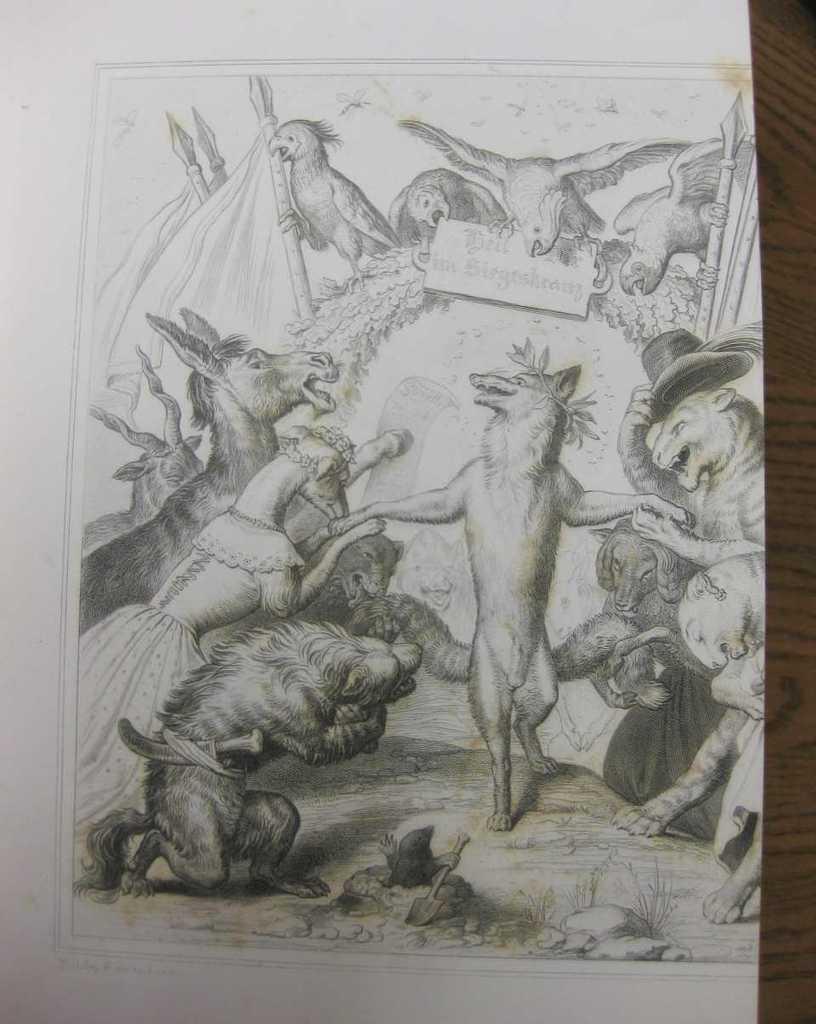How would you summarize this image in a sentence or two? In this picture we have a pencil sketch. In this drawing we have many animals in the jungle. 